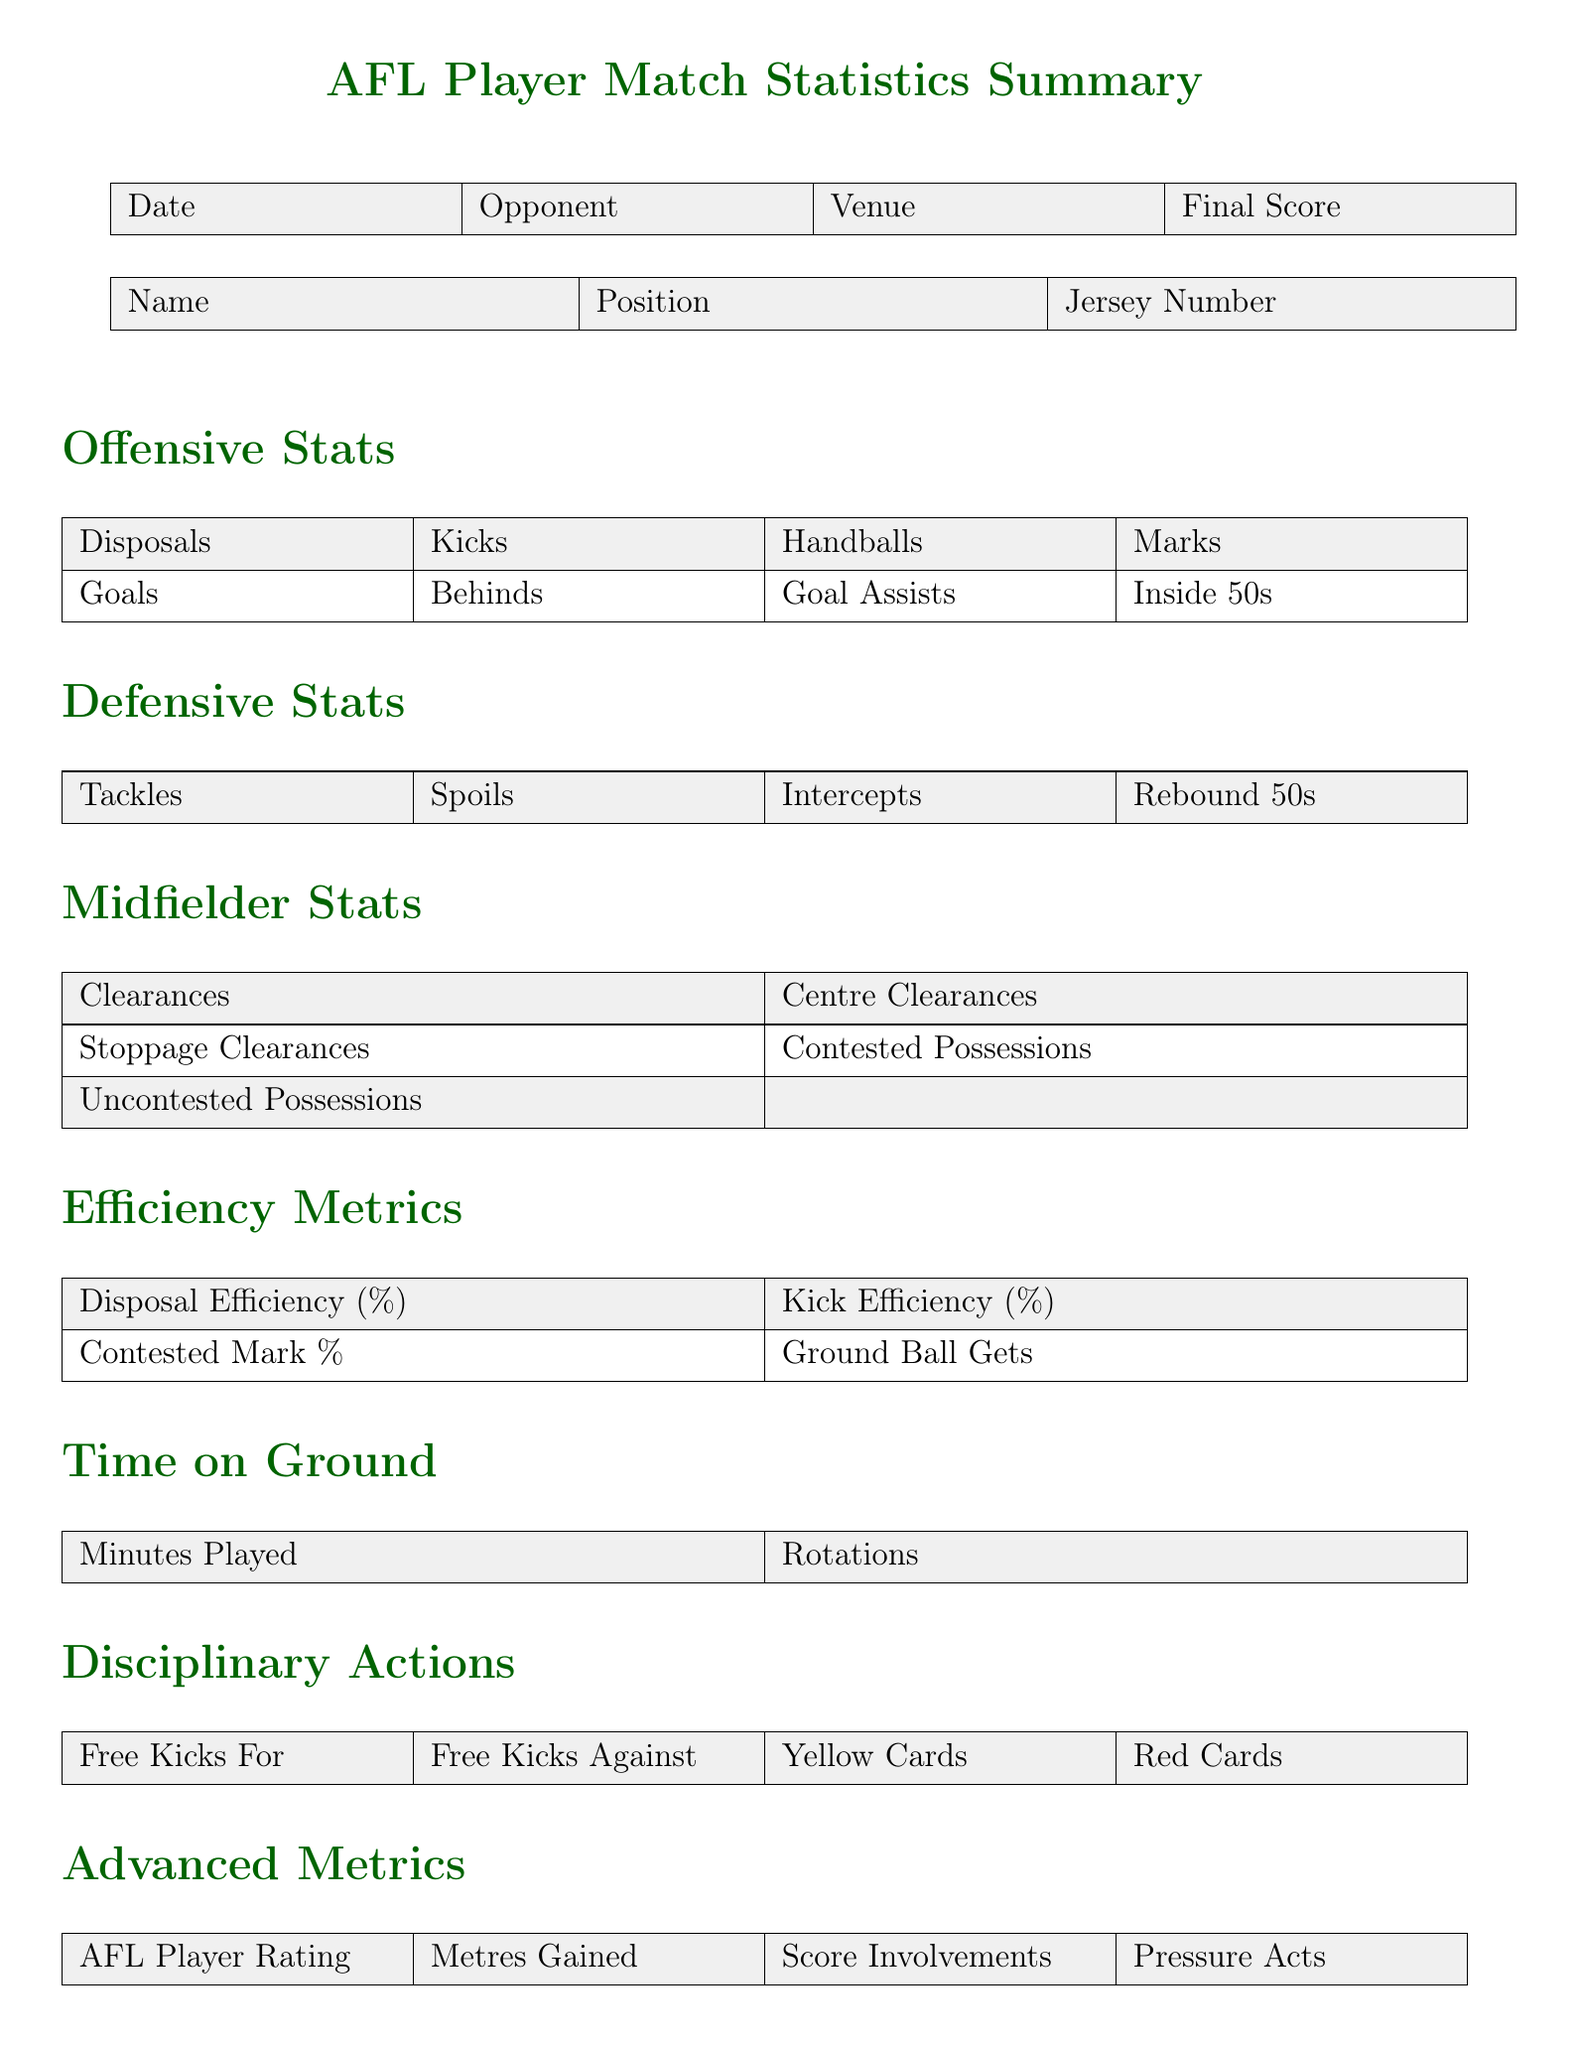what is the title of the document? The title of the document is stated at the top and describes the content, specifically referring to player statistics in a match.
Answer: AFL Player Match Statistics Summary who is the opponent in the match? The opponent is specified as part of the match details.
Answer: Opponent how many goals did the player score? The number of goals is part of the offensive statistics section of the document.
Answer: Goals what is the player's efficiency rating? The efficiency rating can be found in the efficiency metrics section of the document.
Answer: Disposal Efficiency (%) how many minutes did the player play? The minutes played can be found in the time on ground section of the document.
Answer: Minutes Played what category does "Tackles" belong to? "Tackles" is clearly marked as part of the defensive stats in the document.
Answer: Defensive Stats who is noted for having a high AFL Player Rating? The advanced metrics section could provide the name of the player, if mentioned.
Answer: AFL Player Rating what specific areas are noted for improvement? The coach notes section will specify areas where the player can improve.
Answer: Areas for Improvement how many clearances did the player achieve? The number of clearances is included in the midfielder stats section of the document.
Answer: Clearances 